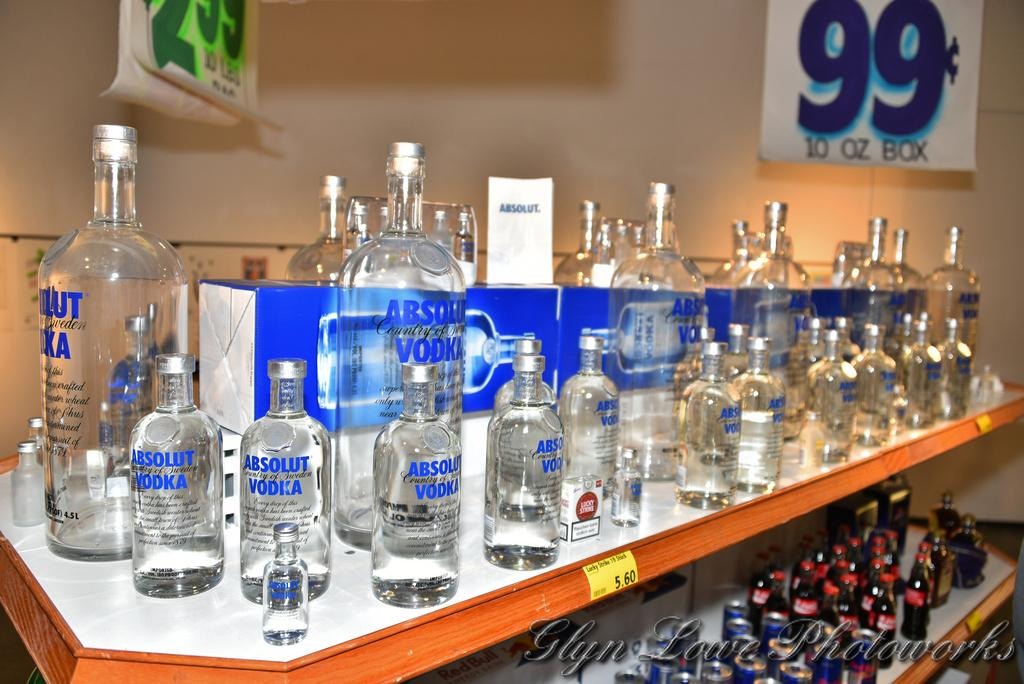What type of containers are visible in the image? There are glass bottles in the image. Where are the glass bottles located? The glass bottles are on a shelf. What can be seen in the background of the image? There is a wall and banners in the background of the image. What type of loaf is being toasted in the image? There is no loaf or toaster present in the image; it only features glass bottles on a shelf and a background with a wall and banners. 